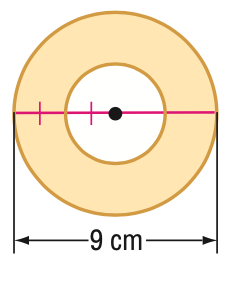Question: Find the area of the shaded region.
Choices:
A. 14.1
B. 15.9
C. 47.7
D. 63.6
Answer with the letter. Answer: C 